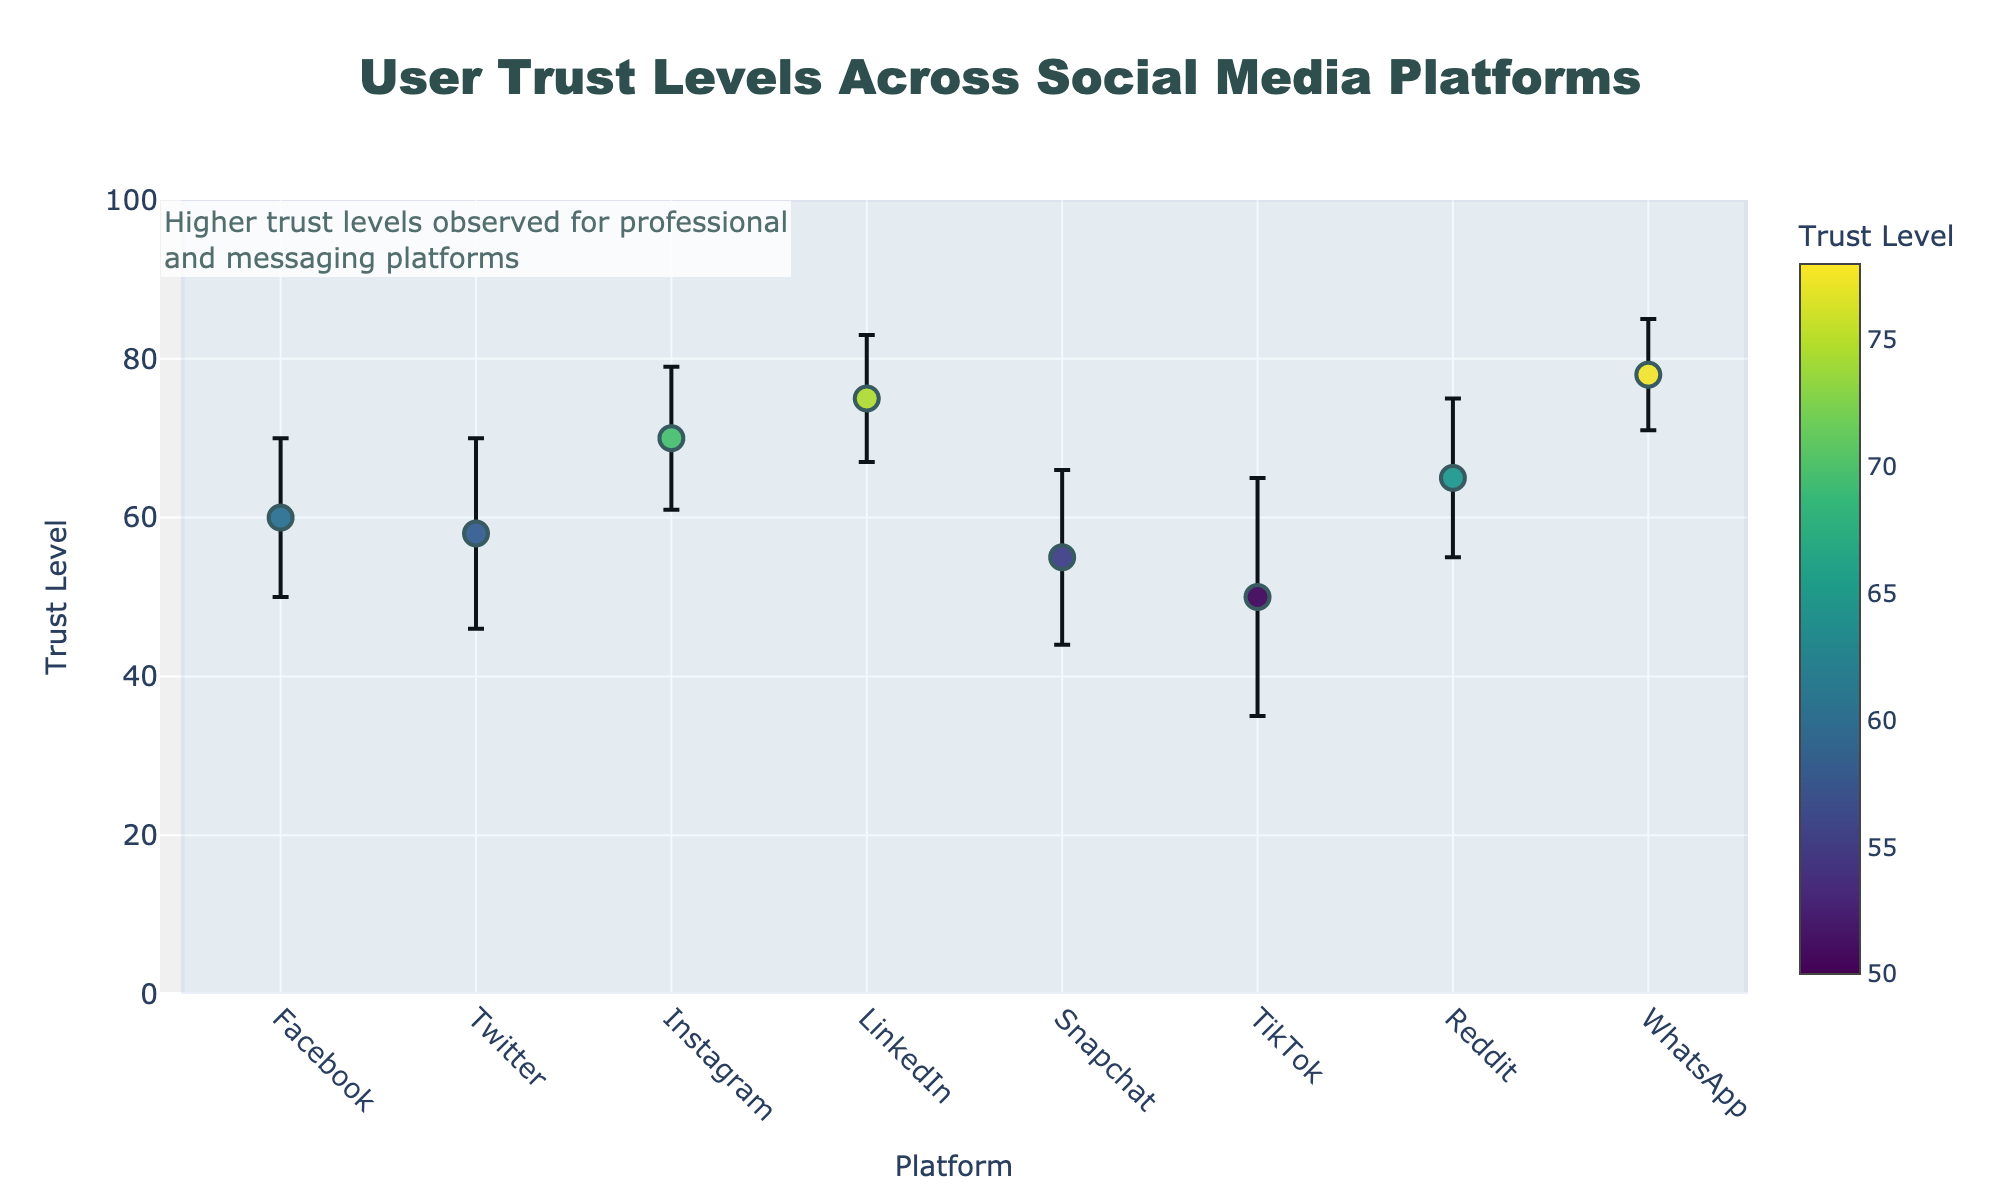What is the title of the plot? The title of a plot is usually located at the top center of the figure. In this case, we can see it clearly written at the top.
Answer: User Trust Levels Across Social Media Platforms Which platform has the highest mean trust level? By looking at the dots on the Y-axis, the highest dot represents the highest mean trust level, which is labeled on the color bar and the X-axis.
Answer: WhatsApp What are the mean trust levels for LinkedIn and TikTok? Locate both LinkedIn and TikTok on the X-axis, follow the markers to the Y-axis, and look at the color intensity.
Answer: LinkedIn: 75, TikTok: 50 How many platforms have a mean trust level greater than 60? Identify platforms on the X-axis with dots above the 60 point on the Y-axis. Count these dots.
Answer: Four platforms Which platform has the largest error bar? Error bars represent standard deviations. The longest line up and down from the dot indicates the largest error bar.
Answer: TikTok What is the difference in mean trust levels between Instagram and Snapchat? Look at the mean trust levels for both Instagram and Snapchat on the Y-axis. Calculate the difference. 70 - 55 = 15.
Answer: 15 Which platform with a mean trust level of more than 70 has the smallest standard deviation? Platforms with mean trust levels above 70 are Instagram, LinkedIn, and WhatsApp. Compare the lengths of their error bars.
Answer: WhatsApp How is user trust level related to the perception of professional vs. messaging platforms, according to the annotation? The annotation notes that higher trust levels are observed for professional and messaging platforms, indicating a perception bias.
Answer: Higher trust levels observed for professional and messaging platforms What is the average standard deviation across all platforms? Sum all the standard deviations and divide by the number of platforms. (10 + 12 + 9 + 8 + 11 + 15 + 10 + 7) / 8 = 10.25.
Answer: 10.25 